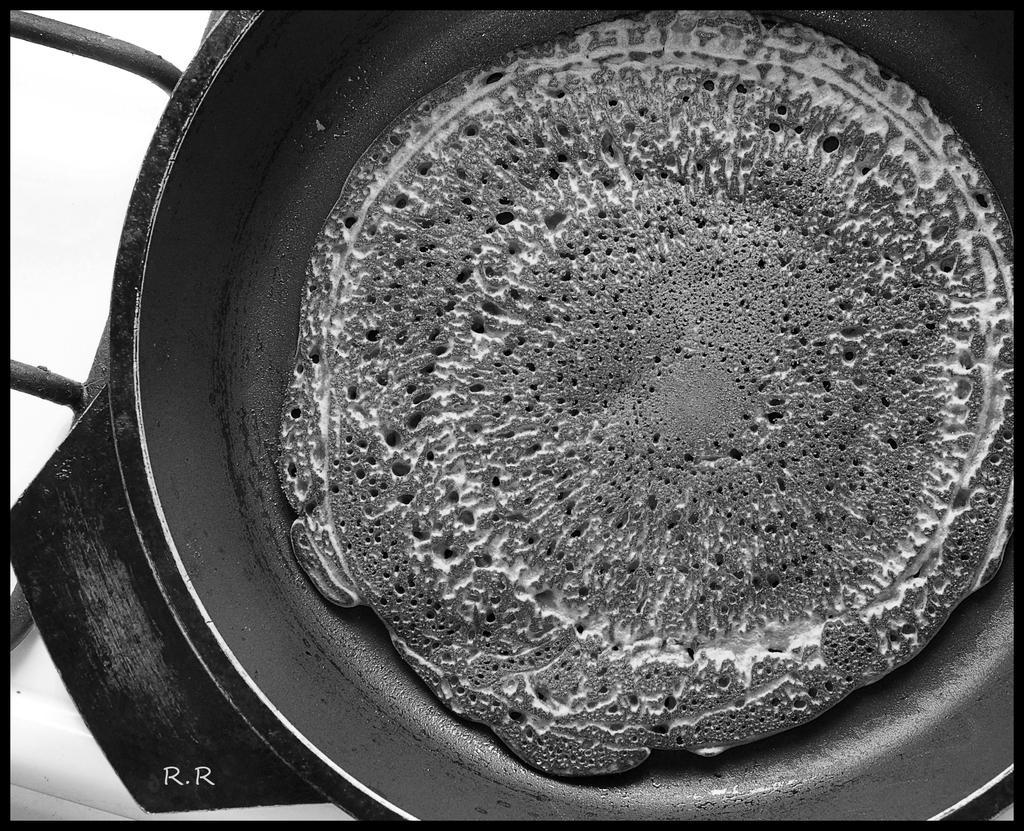How would you summarize this image in a sentence or two? There is a black color pant which has some eatables placed in it. 